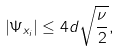Convert formula to latex. <formula><loc_0><loc_0><loc_500><loc_500>\left | \Psi _ { x _ { i } } \right | \leq 4 d \sqrt { \frac { \nu } { 2 } } ,</formula> 